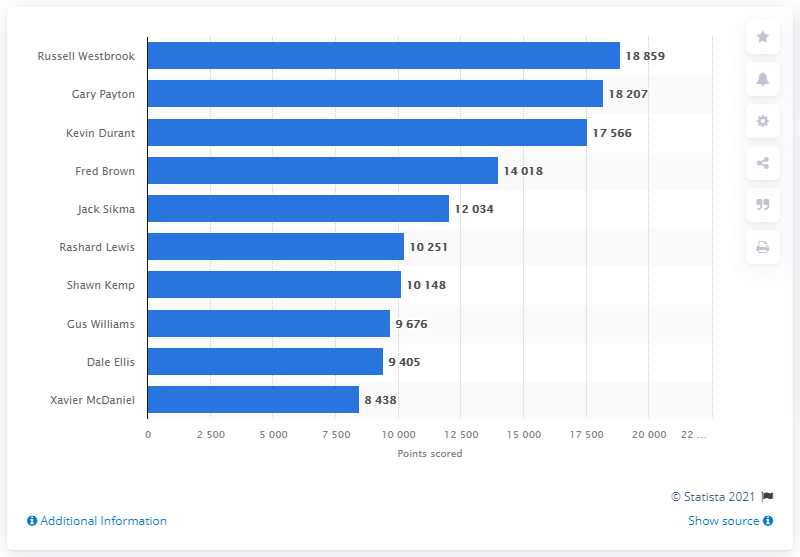Highlight a few significant elements in this photo. The Oklahoma City Thunder's career points leader is none other than Russell Westbrook. 